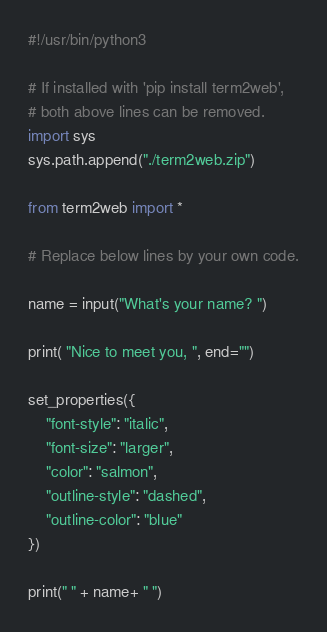Convert code to text. <code><loc_0><loc_0><loc_500><loc_500><_Python_>#!/usr/bin/python3

# If installed with 'pip install term2web',
# both above lines can be removed.
import sys
sys.path.append("./term2web.zip")

from term2web import *

# Replace below lines by your own code.

name = input("What's your name? ")

print( "Nice to meet you, ", end="")

set_properties({
    "font-style": "italic",
    "font-size": "larger",
    "color": "salmon",
    "outline-style": "dashed",
    "outline-color": "blue"
})

print(" " + name+ " ")

</code> 